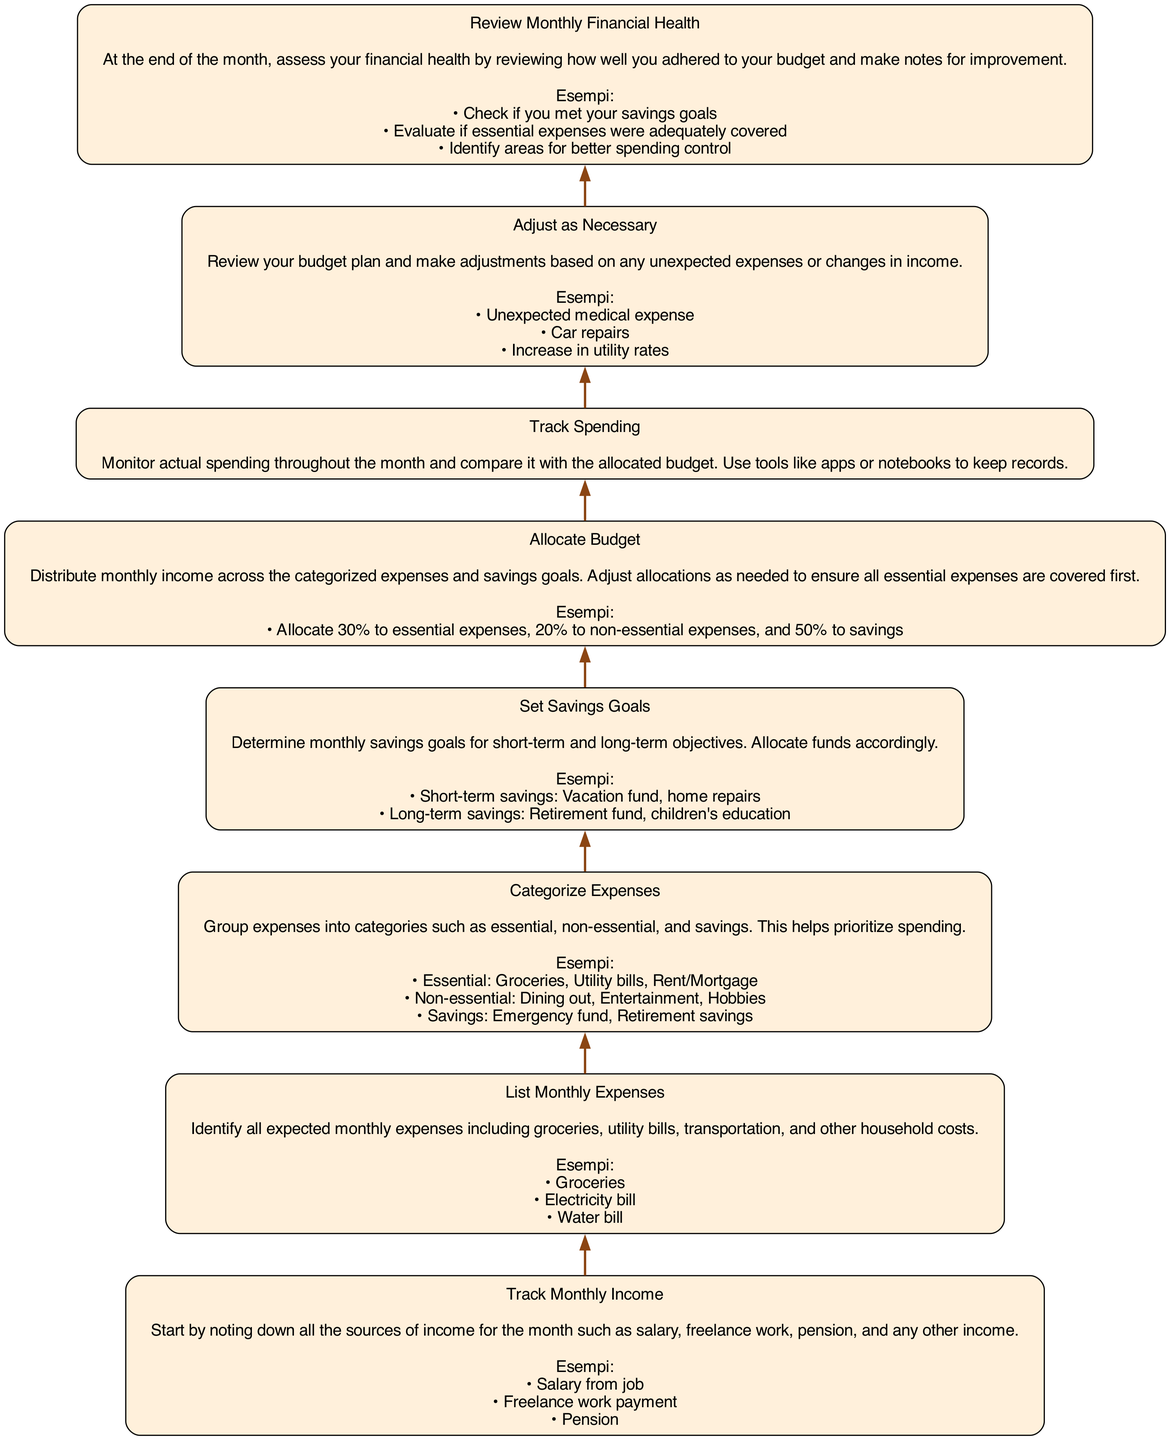What is the first step in managing a monthly budget? The first step as indicated in the diagram is "Track Monthly Income". This action initiates the budget management process by identifying all possible income sources for the month.
Answer: Track Monthly Income How many categories are expenses divided into? The diagram details that expenses are categorized into three groups: essential, non-essential, and savings. This simplifies prioritization of spending.
Answer: Three Which node directly follows "Set Savings Goals"? In the flow of the diagram, "Set Savings Goals" is directly followed by the node "Allocate Budget". This indicates the next step in the budgeting process after setting goals.
Answer: Allocate Budget What should you monitor throughout the month? The diagram suggests that you should "Track Spending" throughout the month to compare actual expenses with your budgeted amounts.
Answer: Track Spending What is necessary to adjust in the budgeting process? The diagram indicates that after tracking spending, it may be necessary to "Adjust as Necessary" if there are unexpected expenses or income changes impacting your budget allocation.
Answer: Adjust as Necessary Before reviewing your monthly financial health, what must be done? The diagram specifies that the last step before reviewing financial health is to "Adjust as Necessary". This ensures that your budget is up-to-date before assessment.
Answer: Adjust as Necessary What is an example of a short-term savings goal? The diagram provides an example of a short-term savings goal as a "Vacation fund". This represents a specific financial aim for immediate future spending.
Answer: Vacation fund What is the purpose of categorizing expenses? The purpose of categorizing expenses, as described in the diagram, is to help prioritize spending. This ensures that essential needs are met before non-essential expenses or savings.
Answer: Prioritize spending What types of tools are suggested for tracking spending? The diagram lists tools such as "Notebook and pen" and "Budget tracking apps like YNAB or Mint" for keeping track of expenditure throughout the month.
Answer: Notebook and Budget tracking apps What should you include in your budget allocation? According to the diagram, when allocating your budget, you should include "essential expenses, non-essential expenses, and savings goals" to manage your finances effectively.
Answer: Essential and non-essential expenses and savings goals 